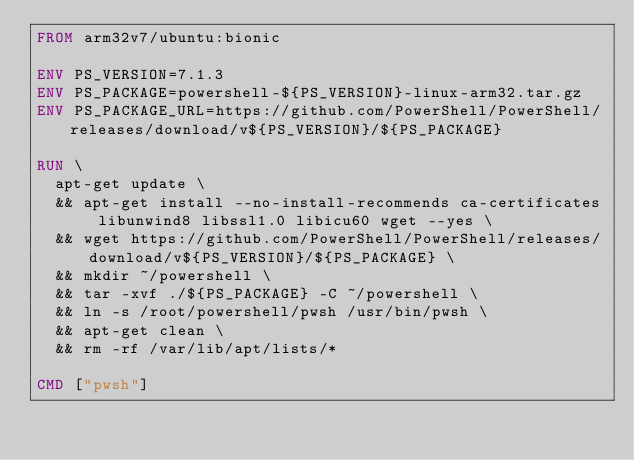<code> <loc_0><loc_0><loc_500><loc_500><_Dockerfile_>FROM arm32v7/ubuntu:bionic

ENV PS_VERSION=7.1.3
ENV PS_PACKAGE=powershell-${PS_VERSION}-linux-arm32.tar.gz
ENV PS_PACKAGE_URL=https://github.com/PowerShell/PowerShell/releases/download/v${PS_VERSION}/${PS_PACKAGE}

RUN \
  apt-get update \
  && apt-get install --no-install-recommends ca-certificates libunwind8 libssl1.0 libicu60 wget --yes \
  && wget https://github.com/PowerShell/PowerShell/releases/download/v${PS_VERSION}/${PS_PACKAGE} \
  && mkdir ~/powershell \
  && tar -xvf ./${PS_PACKAGE} -C ~/powershell \
  && ln -s /root/powershell/pwsh /usr/bin/pwsh \
  && apt-get clean \
  && rm -rf /var/lib/apt/lists/*

CMD ["pwsh"]</code> 